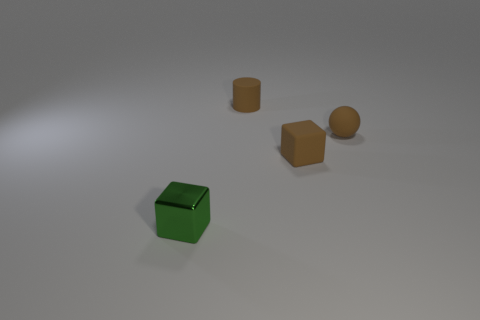There is a brown ball; how many matte objects are behind it?
Offer a very short reply. 1. Are there any cyan balls that have the same material as the small brown sphere?
Offer a terse response. No. There is a small cube that is on the right side of the small metal block; what color is it?
Your response must be concise. Brown. Is the number of brown matte balls left of the brown rubber block the same as the number of tiny matte spheres right of the sphere?
Give a very brief answer. Yes. What material is the tiny brown thing that is right of the small cube that is right of the tiny shiny block?
Your answer should be very brief. Rubber. What number of objects are either cyan metal cylinders or cubes that are right of the small metallic block?
Provide a short and direct response. 1. Is the number of tiny things that are right of the green metal object greater than the number of blue balls?
Keep it short and to the point. Yes. There is a rubber object that is to the left of the brown matte cube; is its size the same as the green cube?
Keep it short and to the point. Yes. What is the color of the small object that is left of the brown matte cube and behind the tiny green metallic block?
Keep it short and to the point. Brown. There is a tiny thing that is right of the small brown cube; how many rubber things are in front of it?
Offer a terse response. 1. 